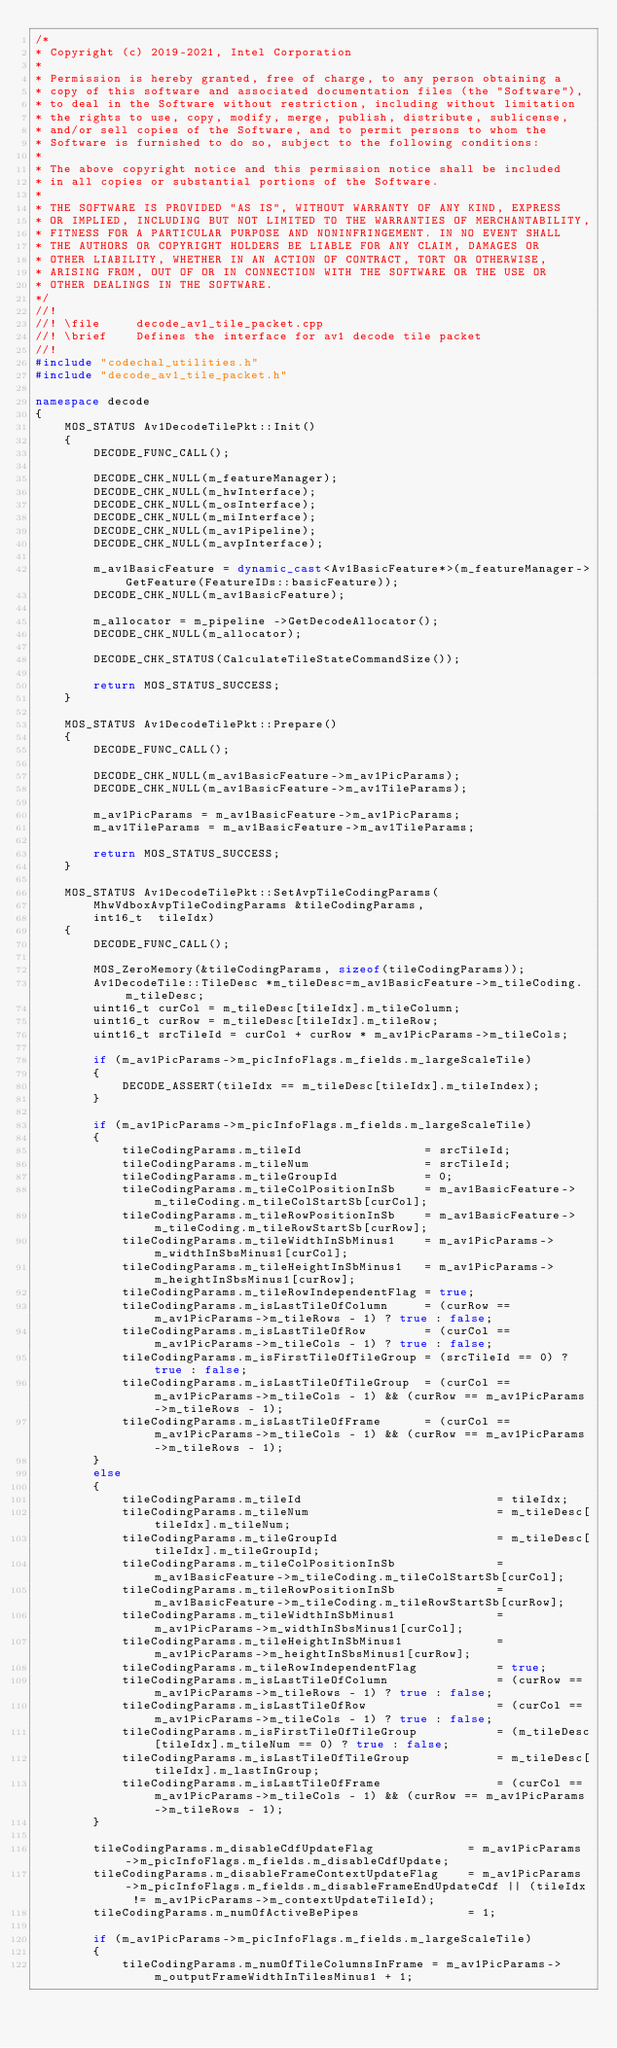<code> <loc_0><loc_0><loc_500><loc_500><_C++_>/*
* Copyright (c) 2019-2021, Intel Corporation
*
* Permission is hereby granted, free of charge, to any person obtaining a
* copy of this software and associated documentation files (the "Software"),
* to deal in the Software without restriction, including without limitation
* the rights to use, copy, modify, merge, publish, distribute, sublicense,
* and/or sell copies of the Software, and to permit persons to whom the
* Software is furnished to do so, subject to the following conditions:
*
* The above copyright notice and this permission notice shall be included
* in all copies or substantial portions of the Software.
*
* THE SOFTWARE IS PROVIDED "AS IS", WITHOUT WARRANTY OF ANY KIND, EXPRESS
* OR IMPLIED, INCLUDING BUT NOT LIMITED TO THE WARRANTIES OF MERCHANTABILITY,
* FITNESS FOR A PARTICULAR PURPOSE AND NONINFRINGEMENT. IN NO EVENT SHALL
* THE AUTHORS OR COPYRIGHT HOLDERS BE LIABLE FOR ANY CLAIM, DAMAGES OR
* OTHER LIABILITY, WHETHER IN AN ACTION OF CONTRACT, TORT OR OTHERWISE,
* ARISING FROM, OUT OF OR IN CONNECTION WITH THE SOFTWARE OR THE USE OR
* OTHER DEALINGS IN THE SOFTWARE.
*/
//!
//! \file     decode_av1_tile_packet.cpp
//! \brief    Defines the interface for av1 decode tile packet
//!
#include "codechal_utilities.h"
#include "decode_av1_tile_packet.h"

namespace decode
{
    MOS_STATUS Av1DecodeTilePkt::Init()
    {
        DECODE_FUNC_CALL();

        DECODE_CHK_NULL(m_featureManager);
        DECODE_CHK_NULL(m_hwInterface);
        DECODE_CHK_NULL(m_osInterface);
        DECODE_CHK_NULL(m_miInterface);
        DECODE_CHK_NULL(m_av1Pipeline);
        DECODE_CHK_NULL(m_avpInterface);

        m_av1BasicFeature = dynamic_cast<Av1BasicFeature*>(m_featureManager->GetFeature(FeatureIDs::basicFeature));
        DECODE_CHK_NULL(m_av1BasicFeature);

        m_allocator = m_pipeline ->GetDecodeAllocator();
        DECODE_CHK_NULL(m_allocator);

        DECODE_CHK_STATUS(CalculateTileStateCommandSize());

        return MOS_STATUS_SUCCESS;
    }

    MOS_STATUS Av1DecodeTilePkt::Prepare()
    {
        DECODE_FUNC_CALL();

        DECODE_CHK_NULL(m_av1BasicFeature->m_av1PicParams);
        DECODE_CHK_NULL(m_av1BasicFeature->m_av1TileParams);

        m_av1PicParams = m_av1BasicFeature->m_av1PicParams;
        m_av1TileParams = m_av1BasicFeature->m_av1TileParams;

        return MOS_STATUS_SUCCESS;
    }

    MOS_STATUS Av1DecodeTilePkt::SetAvpTileCodingParams(
        MhwVdboxAvpTileCodingParams &tileCodingParams,
        int16_t  tileIdx)
    {
        DECODE_FUNC_CALL();

        MOS_ZeroMemory(&tileCodingParams, sizeof(tileCodingParams));
        Av1DecodeTile::TileDesc *m_tileDesc=m_av1BasicFeature->m_tileCoding.m_tileDesc;
        uint16_t curCol = m_tileDesc[tileIdx].m_tileColumn;
        uint16_t curRow = m_tileDesc[tileIdx].m_tileRow;
        uint16_t srcTileId = curCol + curRow * m_av1PicParams->m_tileCols;

        if (m_av1PicParams->m_picInfoFlags.m_fields.m_largeScaleTile)
        {
            DECODE_ASSERT(tileIdx == m_tileDesc[tileIdx].m_tileIndex);
        }

        if (m_av1PicParams->m_picInfoFlags.m_fields.m_largeScaleTile)
        {
            tileCodingParams.m_tileId                 = srcTileId;
            tileCodingParams.m_tileNum                = srcTileId;
            tileCodingParams.m_tileGroupId            = 0;
            tileCodingParams.m_tileColPositionInSb    = m_av1BasicFeature->m_tileCoding.m_tileColStartSb[curCol];
            tileCodingParams.m_tileRowPositionInSb    = m_av1BasicFeature->m_tileCoding.m_tileRowStartSb[curRow];
            tileCodingParams.m_tileWidthInSbMinus1    = m_av1PicParams->m_widthInSbsMinus1[curCol];
            tileCodingParams.m_tileHeightInSbMinus1   = m_av1PicParams->m_heightInSbsMinus1[curRow];
            tileCodingParams.m_tileRowIndependentFlag = true;
            tileCodingParams.m_isLastTileOfColumn     = (curRow == m_av1PicParams->m_tileRows - 1) ? true : false;
            tileCodingParams.m_isLastTileOfRow        = (curCol == m_av1PicParams->m_tileCols - 1) ? true : false;
            tileCodingParams.m_isFirstTileOfTileGroup = (srcTileId == 0) ? true : false;
            tileCodingParams.m_isLastTileOfTileGroup  = (curCol == m_av1PicParams->m_tileCols - 1) && (curRow == m_av1PicParams->m_tileRows - 1);
            tileCodingParams.m_isLastTileOfFrame      = (curCol == m_av1PicParams->m_tileCols - 1) && (curRow == m_av1PicParams->m_tileRows - 1);
        }
        else
        {
            tileCodingParams.m_tileId                           = tileIdx;
            tileCodingParams.m_tileNum                          = m_tileDesc[tileIdx].m_tileNum;
            tileCodingParams.m_tileGroupId                      = m_tileDesc[tileIdx].m_tileGroupId;
            tileCodingParams.m_tileColPositionInSb              = m_av1BasicFeature->m_tileCoding.m_tileColStartSb[curCol];
            tileCodingParams.m_tileRowPositionInSb              = m_av1BasicFeature->m_tileCoding.m_tileRowStartSb[curRow];
            tileCodingParams.m_tileWidthInSbMinus1              = m_av1PicParams->m_widthInSbsMinus1[curCol];
            tileCodingParams.m_tileHeightInSbMinus1             = m_av1PicParams->m_heightInSbsMinus1[curRow];
            tileCodingParams.m_tileRowIndependentFlag           = true;
            tileCodingParams.m_isLastTileOfColumn               = (curRow == m_av1PicParams->m_tileRows - 1) ? true : false;
            tileCodingParams.m_isLastTileOfRow                  = (curCol == m_av1PicParams->m_tileCols - 1) ? true : false;
            tileCodingParams.m_isFirstTileOfTileGroup           = (m_tileDesc[tileIdx].m_tileNum == 0) ? true : false;
            tileCodingParams.m_isLastTileOfTileGroup            = m_tileDesc[tileIdx].m_lastInGroup;
            tileCodingParams.m_isLastTileOfFrame                = (curCol == m_av1PicParams->m_tileCols - 1) && (curRow == m_av1PicParams->m_tileRows - 1);
        }

        tileCodingParams.m_disableCdfUpdateFlag             = m_av1PicParams->m_picInfoFlags.m_fields.m_disableCdfUpdate;
        tileCodingParams.m_disableFrameContextUpdateFlag    = m_av1PicParams->m_picInfoFlags.m_fields.m_disableFrameEndUpdateCdf || (tileIdx != m_av1PicParams->m_contextUpdateTileId);
        tileCodingParams.m_numOfActiveBePipes               = 1;

        if (m_av1PicParams->m_picInfoFlags.m_fields.m_largeScaleTile)
        {
            tileCodingParams.m_numOfTileColumnsInFrame = m_av1PicParams->m_outputFrameWidthInTilesMinus1 + 1;</code> 